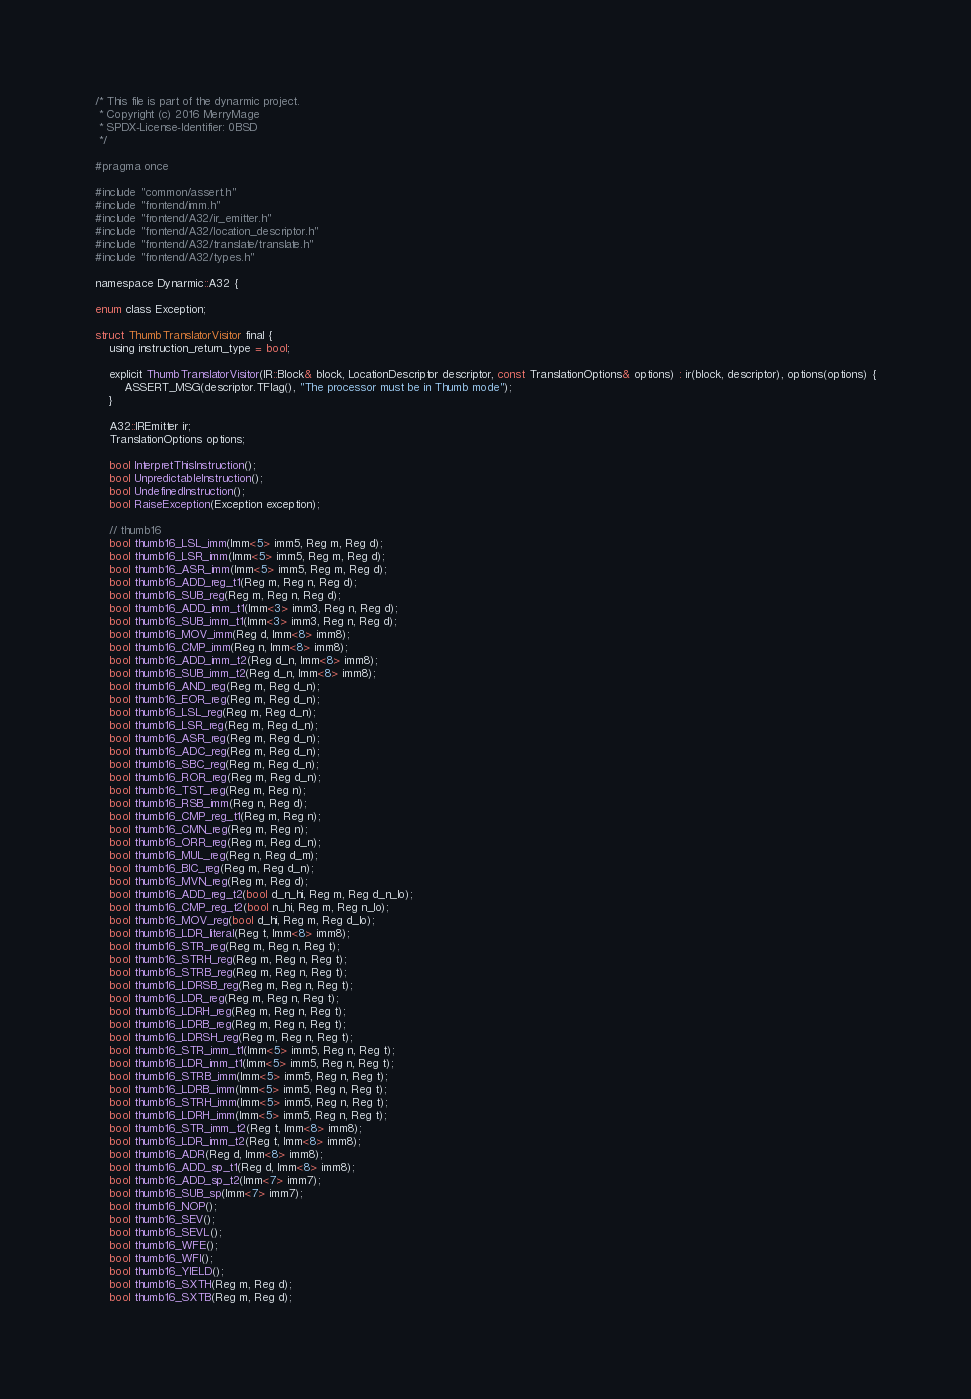Convert code to text. <code><loc_0><loc_0><loc_500><loc_500><_C_>/* This file is part of the dynarmic project.
 * Copyright (c) 2016 MerryMage
 * SPDX-License-Identifier: 0BSD
 */

#pragma once

#include "common/assert.h"
#include "frontend/imm.h"
#include "frontend/A32/ir_emitter.h"
#include "frontend/A32/location_descriptor.h"
#include "frontend/A32/translate/translate.h"
#include "frontend/A32/types.h"

namespace Dynarmic::A32 {

enum class Exception;

struct ThumbTranslatorVisitor final {
    using instruction_return_type = bool;

    explicit ThumbTranslatorVisitor(IR::Block& block, LocationDescriptor descriptor, const TranslationOptions& options) : ir(block, descriptor), options(options) {
        ASSERT_MSG(descriptor.TFlag(), "The processor must be in Thumb mode");
    }

    A32::IREmitter ir;
    TranslationOptions options;

    bool InterpretThisInstruction();
    bool UnpredictableInstruction();
    bool UndefinedInstruction();
    bool RaiseException(Exception exception);

    // thumb16
    bool thumb16_LSL_imm(Imm<5> imm5, Reg m, Reg d);
    bool thumb16_LSR_imm(Imm<5> imm5, Reg m, Reg d);
    bool thumb16_ASR_imm(Imm<5> imm5, Reg m, Reg d);
    bool thumb16_ADD_reg_t1(Reg m, Reg n, Reg d);
    bool thumb16_SUB_reg(Reg m, Reg n, Reg d);
    bool thumb16_ADD_imm_t1(Imm<3> imm3, Reg n, Reg d);
    bool thumb16_SUB_imm_t1(Imm<3> imm3, Reg n, Reg d);
    bool thumb16_MOV_imm(Reg d, Imm<8> imm8);
    bool thumb16_CMP_imm(Reg n, Imm<8> imm8);
    bool thumb16_ADD_imm_t2(Reg d_n, Imm<8> imm8);
    bool thumb16_SUB_imm_t2(Reg d_n, Imm<8> imm8);
    bool thumb16_AND_reg(Reg m, Reg d_n);
    bool thumb16_EOR_reg(Reg m, Reg d_n);
    bool thumb16_LSL_reg(Reg m, Reg d_n);
    bool thumb16_LSR_reg(Reg m, Reg d_n);
    bool thumb16_ASR_reg(Reg m, Reg d_n);
    bool thumb16_ADC_reg(Reg m, Reg d_n);
    bool thumb16_SBC_reg(Reg m, Reg d_n);
    bool thumb16_ROR_reg(Reg m, Reg d_n);
    bool thumb16_TST_reg(Reg m, Reg n);
    bool thumb16_RSB_imm(Reg n, Reg d);
    bool thumb16_CMP_reg_t1(Reg m, Reg n);
    bool thumb16_CMN_reg(Reg m, Reg n);
    bool thumb16_ORR_reg(Reg m, Reg d_n);
    bool thumb16_MUL_reg(Reg n, Reg d_m);
    bool thumb16_BIC_reg(Reg m, Reg d_n);
    bool thumb16_MVN_reg(Reg m, Reg d);
    bool thumb16_ADD_reg_t2(bool d_n_hi, Reg m, Reg d_n_lo);
    bool thumb16_CMP_reg_t2(bool n_hi, Reg m, Reg n_lo);
    bool thumb16_MOV_reg(bool d_hi, Reg m, Reg d_lo);
    bool thumb16_LDR_literal(Reg t, Imm<8> imm8);
    bool thumb16_STR_reg(Reg m, Reg n, Reg t);
    bool thumb16_STRH_reg(Reg m, Reg n, Reg t);
    bool thumb16_STRB_reg(Reg m, Reg n, Reg t);
    bool thumb16_LDRSB_reg(Reg m, Reg n, Reg t);
    bool thumb16_LDR_reg(Reg m, Reg n, Reg t);
    bool thumb16_LDRH_reg(Reg m, Reg n, Reg t);
    bool thumb16_LDRB_reg(Reg m, Reg n, Reg t);
    bool thumb16_LDRSH_reg(Reg m, Reg n, Reg t);
    bool thumb16_STR_imm_t1(Imm<5> imm5, Reg n, Reg t);
    bool thumb16_LDR_imm_t1(Imm<5> imm5, Reg n, Reg t);
    bool thumb16_STRB_imm(Imm<5> imm5, Reg n, Reg t);
    bool thumb16_LDRB_imm(Imm<5> imm5, Reg n, Reg t);
    bool thumb16_STRH_imm(Imm<5> imm5, Reg n, Reg t);
    bool thumb16_LDRH_imm(Imm<5> imm5, Reg n, Reg t);
    bool thumb16_STR_imm_t2(Reg t, Imm<8> imm8);
    bool thumb16_LDR_imm_t2(Reg t, Imm<8> imm8);
    bool thumb16_ADR(Reg d, Imm<8> imm8);
    bool thumb16_ADD_sp_t1(Reg d, Imm<8> imm8);
    bool thumb16_ADD_sp_t2(Imm<7> imm7);
    bool thumb16_SUB_sp(Imm<7> imm7);
    bool thumb16_NOP();
    bool thumb16_SEV();
    bool thumb16_SEVL();
    bool thumb16_WFE();
    bool thumb16_WFI();
    bool thumb16_YIELD();
    bool thumb16_SXTH(Reg m, Reg d);
    bool thumb16_SXTB(Reg m, Reg d);</code> 